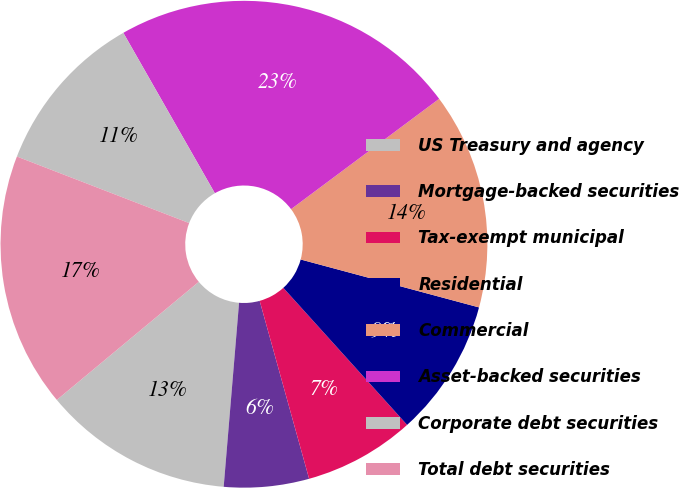<chart> <loc_0><loc_0><loc_500><loc_500><pie_chart><fcel>US Treasury and agency<fcel>Mortgage-backed securities<fcel>Tax-exempt municipal<fcel>Residential<fcel>Commercial<fcel>Asset-backed securities<fcel>Corporate debt securities<fcel>Total debt securities<nl><fcel>12.63%<fcel>5.64%<fcel>7.38%<fcel>9.13%<fcel>14.37%<fcel>23.06%<fcel>10.88%<fcel>16.91%<nl></chart> 